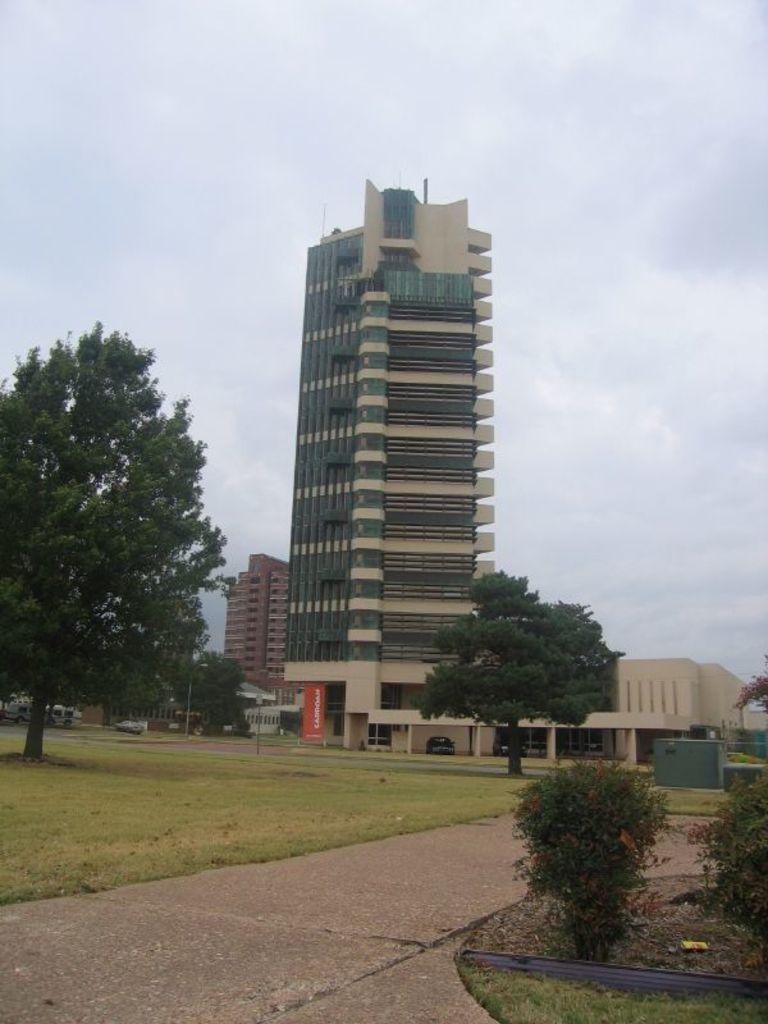What type of living organisms can be seen in the image? Plants and trees are visible in the image. What type of man-made structures can be seen in the image? There are generator boxes, buildings, and banners in the image. What is the surface of the ground like in the image? There is grass on the surface in the image. What type of vehicles can be seen in the image? There are cars on the roads in the image. What is visible at the top of the image? The sky is visible at the top of the image. Where is the cup of coffee being sold in the image? There is no cup of coffee or any indication of a market in the image. What type of paper is being used to wrap the items in the image? There is no paper visible in the image, and no items are being wrapped. 